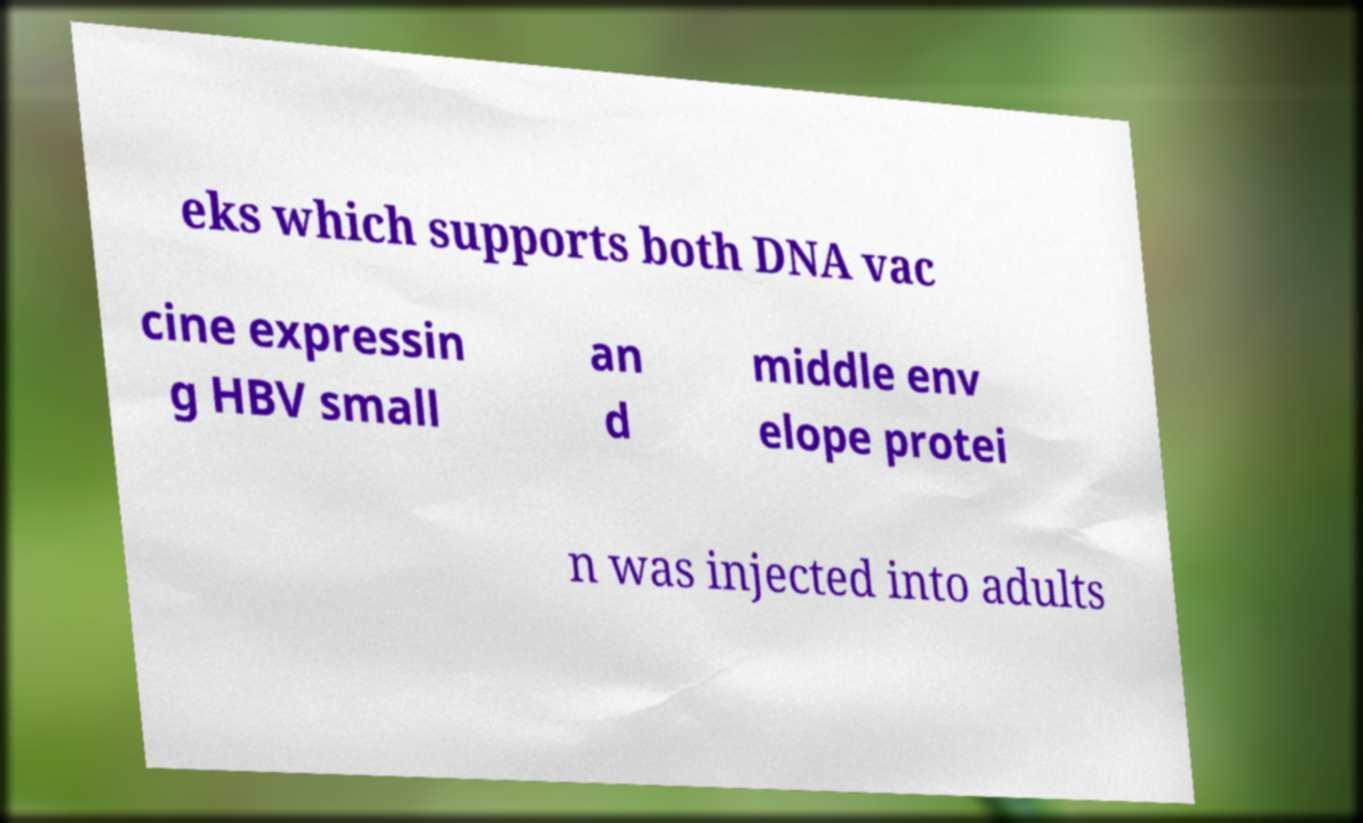Please identify and transcribe the text found in this image. eks which supports both DNA vac cine expressin g HBV small an d middle env elope protei n was injected into adults 